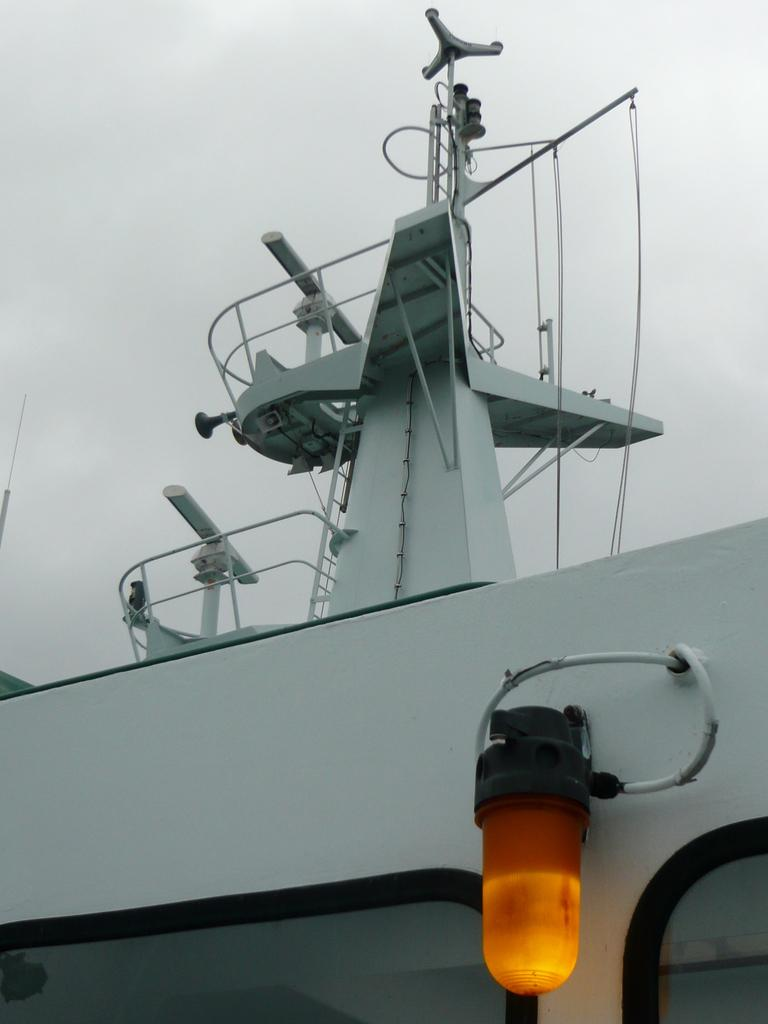What is the source of light in the image? There is a light in the image. What else can be seen in the image besides the light? There are wires and white fences visible in the image. What type of structure is depicted in the image? It appears to be a ship in the image. What is visible at the top of the image? The sky is visible at the top of the image. Can you see a heart-shaped pattern on the ship's sails in the image? There is no heart-shaped pattern visible on the ship's sails in the image. Are there any stockings hanging from the light in the image? There are no stockings present in the image. 